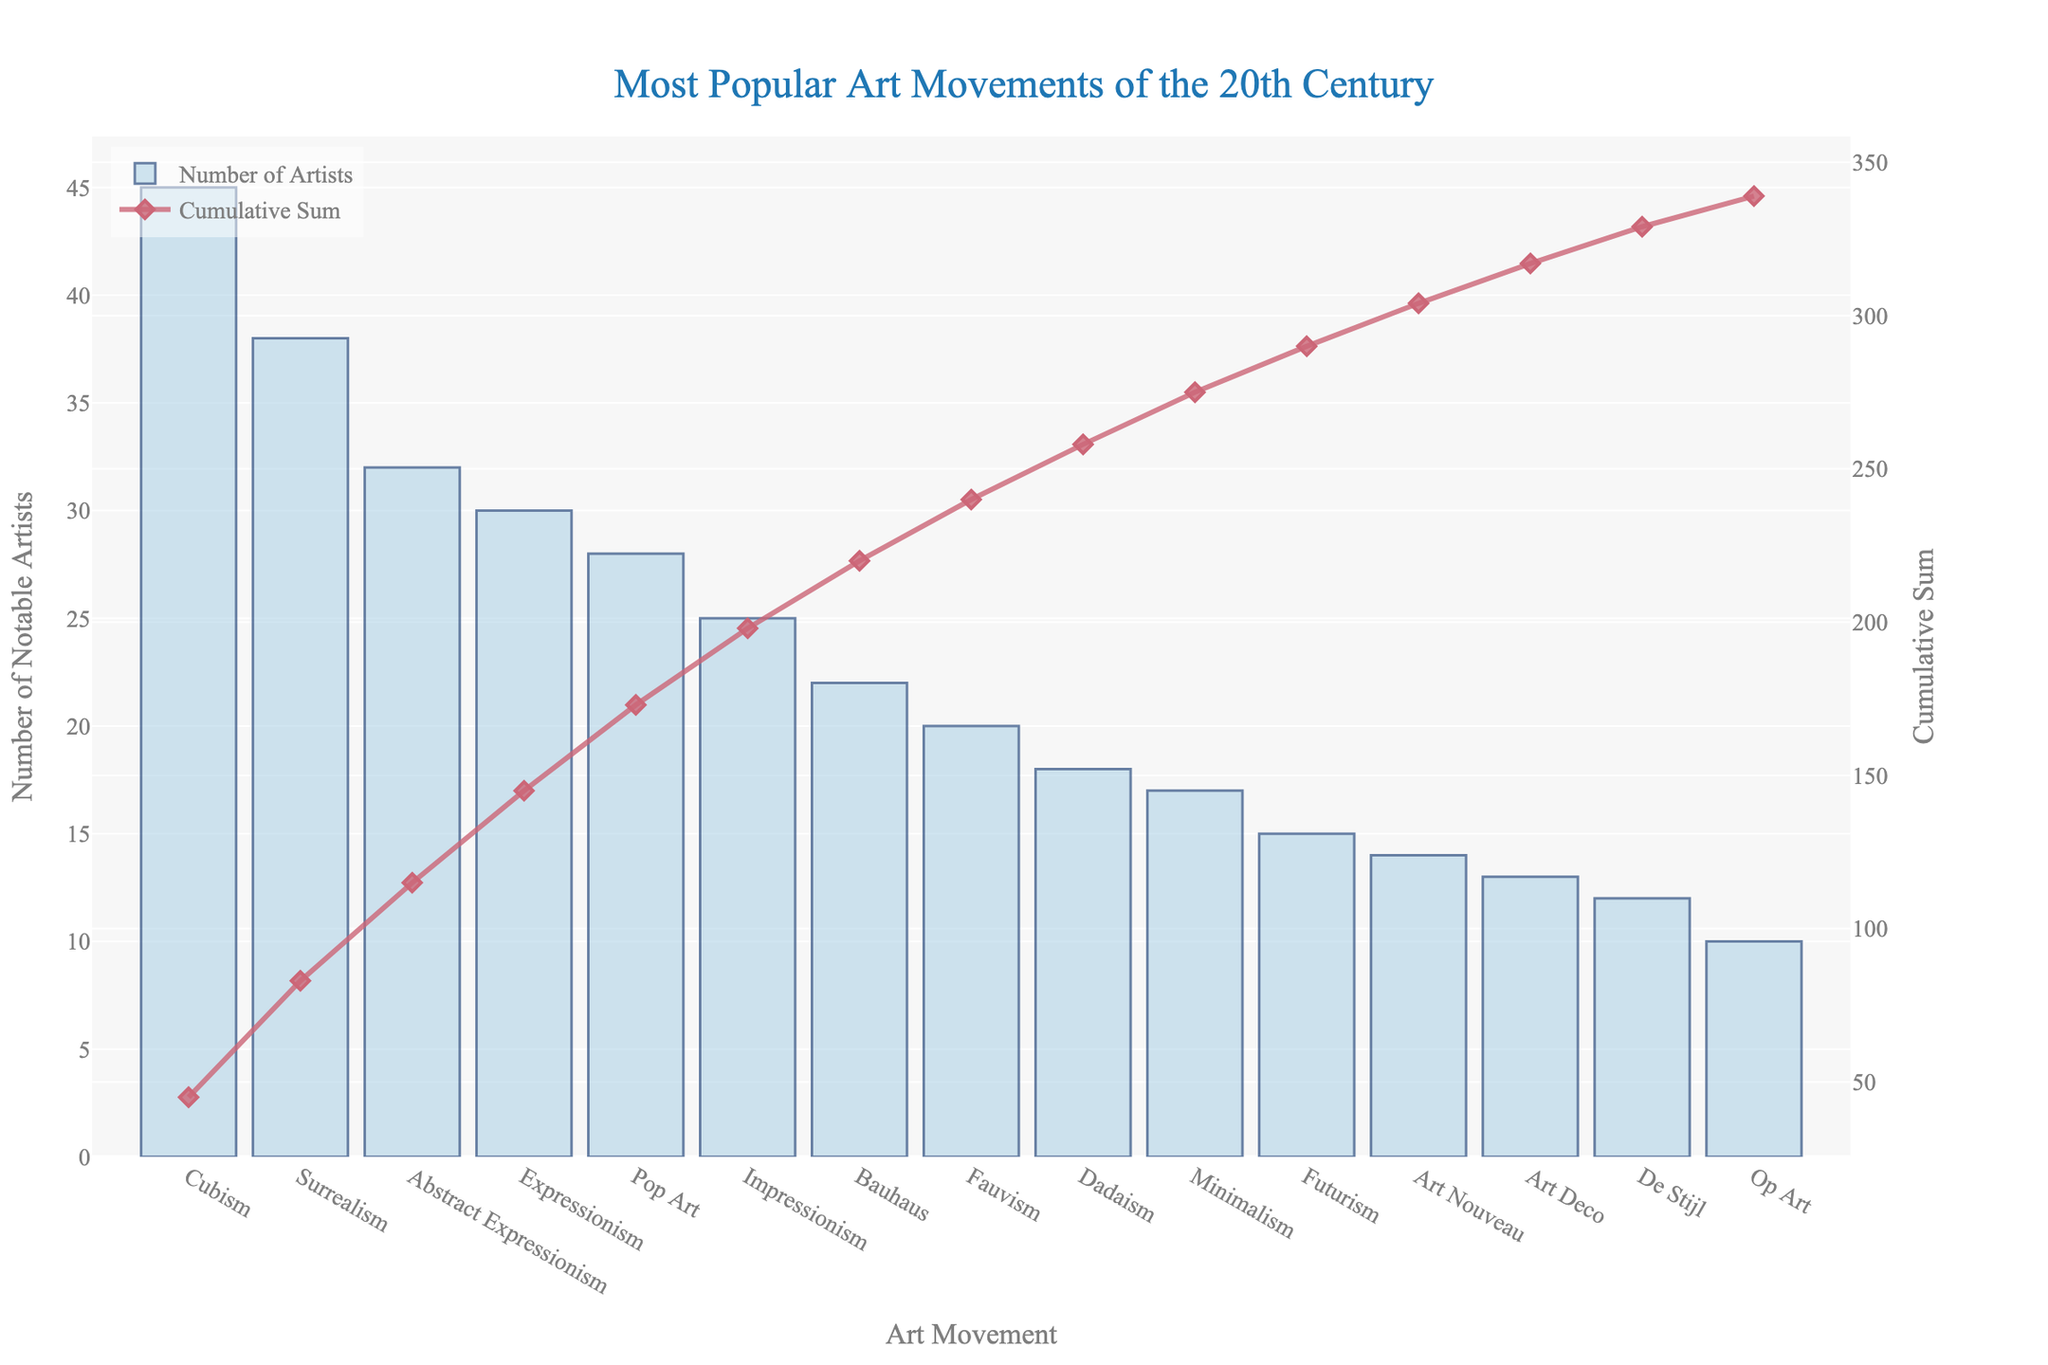Which art movement has the highest number of notable artists? The bar with the highest value indicates the art movement with the most notable artists. The tallest bar corresponds to Cubism.
Answer: Cubism Which art movement has a cumulative sum just under 100 when the bar heights are summed sequentially? Look at the line trace representing the cumulative sum. Identify the point where the cumulative sum is just under 100. This point is just before Pop Art. Summing artists for Cubism, Surrealism, Abstract Expressionism, and Expressionism gives us 145.
Answer: Expressionism What is the difference in the number of notable artists between Cubism and Minimalism? Refer to the heights of the bars for Cubism and Minimalism. Subtract the number of notable artists in Minimalism from that in Cubism (45 - 17).
Answer: 28 Which art movement ranks third in terms of the number of notable artists? Identify the third highest bar in the plot. The first highest bar is Cubism, the second is Surrealism, and the third is Abstract Expressionism.
Answer: Abstract Expressionism What is the ratio of notable artists in Fauvism to notable artists in Pop Art? Divide the number of notable artists in Fauvism by the number of notable artists in Pop Art (20 / 28). Simplify the fraction to get the ratio.
Answer: 5:7 What is the cumulative sum of notable artists after the first five art movements? Sum the number of notable artists for the first five art movements Cubism, Surrealism, Abstract Expressionism, Expressionism, and Pop Art (45 + 38 + 32 + 30 + 28).
Answer: 173 Which two art movements have the closest number of notable artists? Compare the bars' heights to find two art movements with similar values. Bauhaus (22) and Fauvism (20) are close in value.
Answer: Bauhaus and Fauvism Which art movement's cumulative sum intersects at a y-value of approximately 50? Check the line trace representing the cumulative sum to find the point where it reaches around 50. This point appears near the end of Surrealism.
Answer: Surrealism What is the combined number of notable artists in Dadaism, Futurism, and Art Nouveau? Add the number of notable artists for Dadaism, Futurism, and Art Nouveau (18 + 15 + 14).
Answer: 47 Which bar is colored in the lightest shade compared to others? Identify the bar with the lightest shade, representing the least number of notable artists. The Op Art bar has the lightest shade.
Answer: Op Art 